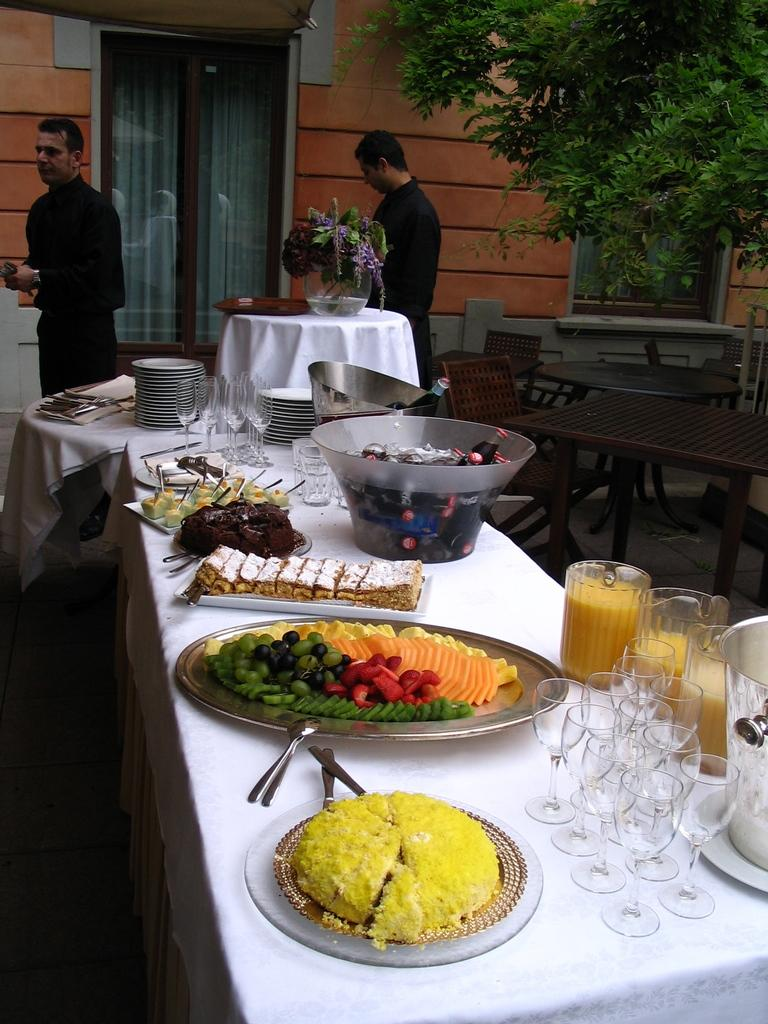What type of natural element is present in the image? There is a tree in the image. What type of man-made structure is present in the image? There is a building in the image. What part of the building can be seen in the image? There is a door in the image. How many people are present in the image? There are two persons standing in the image. What type of furniture is present in the image? There is a table in the image. What items are placed on the table? There are plates and glasses on the table. What type of material is covering the table? There is a white color cloth on the table. What type of statement is written on the locket in the image? There is no locket present in the image. What type of liquid is being poured from the glasses in the image? There is no liquid being poured in the image; the glasses are empty and placed on the table. 